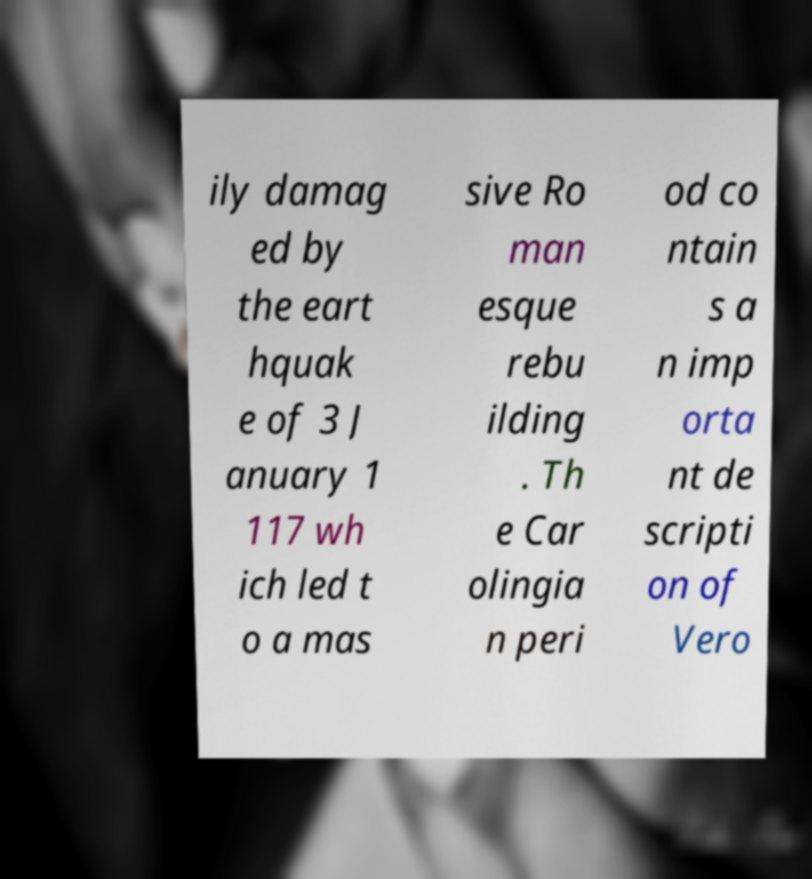What messages or text are displayed in this image? I need them in a readable, typed format. ily damag ed by the eart hquak e of 3 J anuary 1 117 wh ich led t o a mas sive Ro man esque rebu ilding . Th e Car olingia n peri od co ntain s a n imp orta nt de scripti on of Vero 